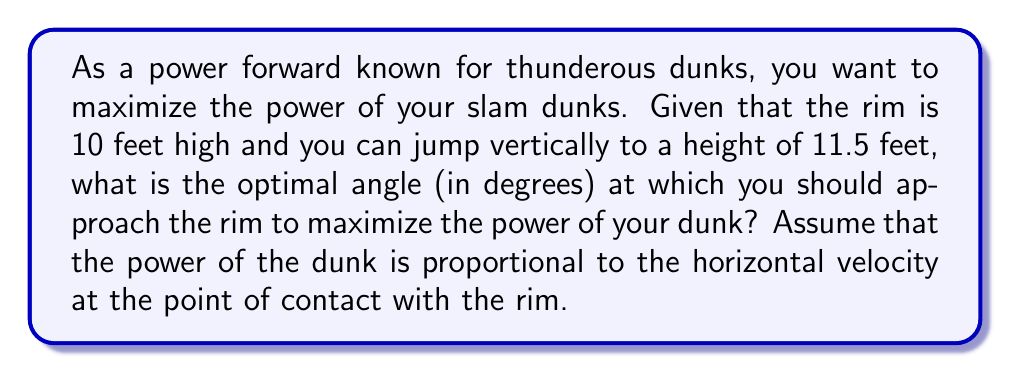Could you help me with this problem? Let's approach this step-by-step:

1) First, we need to understand that the optimal angle will be the one that maximizes horizontal velocity at the rim.

2) We can model this situation as a right triangle, where:
   - The vertical side is the difference between your jump height and the rim height: 11.5 ft - 10 ft = 1.5 ft
   - The hypotenuse is your trajectory from the peak of your jump to the rim
   - The horizontal side is what we want to maximize

3) Let's define θ as the angle between your approach and the horizontal. We want to find θ that maximizes the horizontal distance.

4) The horizontal distance (x) can be expressed as:

   $$x = 1.5 \tan(90° - θ) = 1.5 \cot(θ)$$

5) To find the maximum value of x, we need to differentiate it with respect to θ and set it to zero:

   $$\frac{dx}{dθ} = -1.5 \csc^2(θ) = 0$$

6) This equation is satisfied when θ = 90°, but this is a minimum (vertical approach), not a maximum.

7) The maximum occurs when θ is as small as possible while still allowing you to reach the rim.

8) The smallest possible angle is when your trajectory just touches the rim, forming a right triangle.

9) In this right triangle:
   $$\sin(θ) = \frac{1.5}{1.5} = 1$$

10) Therefore, the optimal angle θ is:

    $$θ = \arcsin(1) = 90°$$

11) However, we need the angle with respect to the horizontal, which is 90° - θ = 0°

[asy]
import geometry;

size(200);
draw((0,0)--(100,0),Arrow);
draw((0,0)--(0,100),Arrow);
draw((0,0)--(100,15),Arrow);

label("Horizontal", (50,-10));
label("Vertical", (-10,50));
label("Trajectory", (50,15));

dot("Rim", (100,0));
dot("Peak of jump", (0,15));

label("1.5 ft", (0,7.5), W);
label("θ", (5,2), NE);
[/asy]
Answer: 0° 